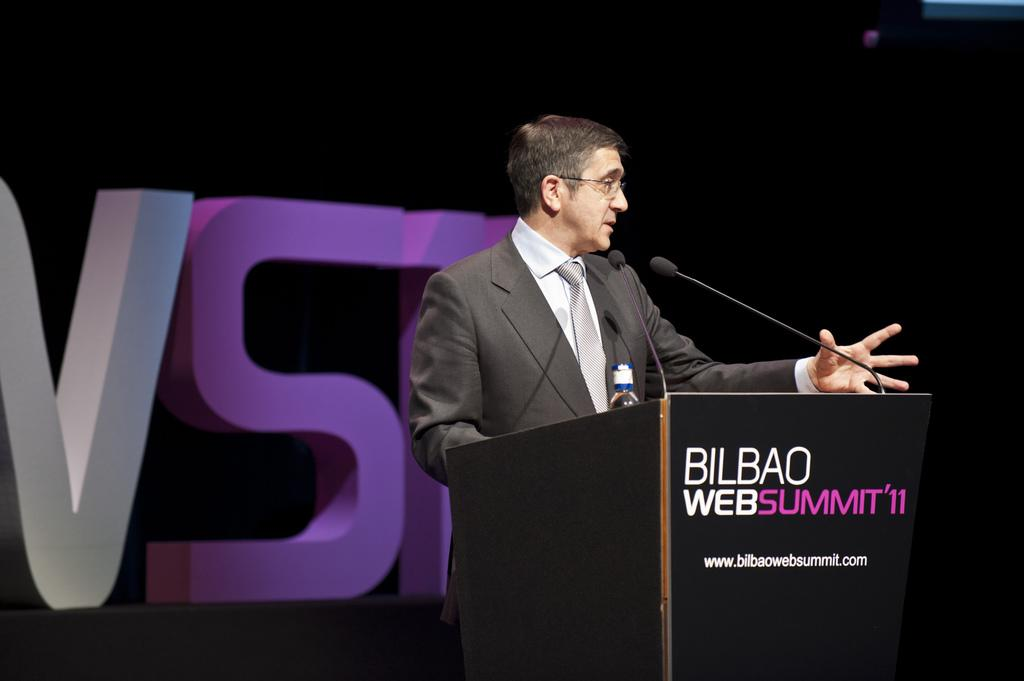What is the main subject of the image? There is a person in the image. What is the person wearing? The person is wearing a suit. What object is present on the table in the image? There is a microphone on the table in the image. What is the color of the background in the image? The background of the image is black. What type of skirt is the person wearing in the image? The person is not wearing a skirt in the image; they are wearing a suit. What language is the person speaking in the image? There is no indication of the person speaking in the image, so it cannot be determined which language they might be using. 